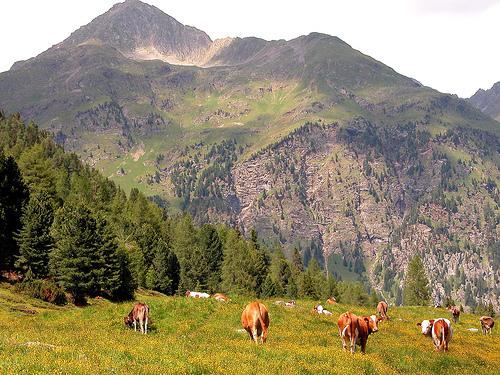How many species can be seen here of mammals? Please explain your reasoning. one. Cattle are the only ones apparent in this image. 